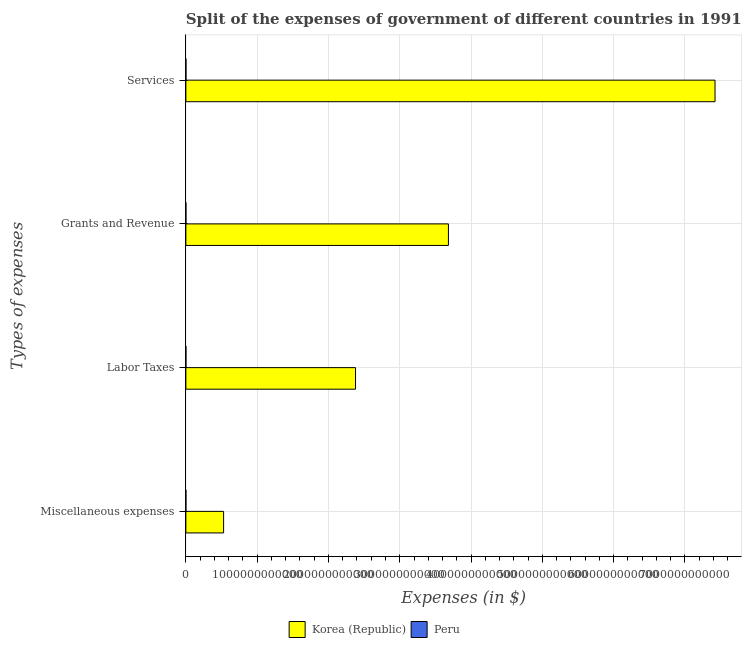How many different coloured bars are there?
Your answer should be compact. 2. How many groups of bars are there?
Your response must be concise. 4. How many bars are there on the 4th tick from the bottom?
Keep it short and to the point. 2. What is the label of the 4th group of bars from the top?
Your answer should be very brief. Miscellaneous expenses. What is the amount spent on grants and revenue in Peru?
Your answer should be compact. 2.74e+08. Across all countries, what is the maximum amount spent on grants and revenue?
Provide a succinct answer. 3.68e+12. Across all countries, what is the minimum amount spent on miscellaneous expenses?
Make the answer very short. 5.00e+06. In which country was the amount spent on grants and revenue maximum?
Offer a very short reply. Korea (Republic). In which country was the amount spent on grants and revenue minimum?
Keep it short and to the point. Peru. What is the total amount spent on labor taxes in the graph?
Your response must be concise. 2.38e+12. What is the difference between the amount spent on miscellaneous expenses in Peru and that in Korea (Republic)?
Provide a short and direct response. -5.29e+11. What is the difference between the amount spent on labor taxes in Peru and the amount spent on grants and revenue in Korea (Republic)?
Ensure brevity in your answer.  -3.68e+12. What is the average amount spent on miscellaneous expenses per country?
Offer a terse response. 2.65e+11. What is the difference between the amount spent on miscellaneous expenses and amount spent on grants and revenue in Korea (Republic)?
Provide a succinct answer. -3.15e+12. In how many countries, is the amount spent on services greater than 3400000000000 $?
Offer a very short reply. 1. What is the ratio of the amount spent on services in Peru to that in Korea (Republic)?
Your answer should be compact. 8.04257038933046e-5. Is the amount spent on miscellaneous expenses in Korea (Republic) less than that in Peru?
Your answer should be very brief. No. What is the difference between the highest and the second highest amount spent on miscellaneous expenses?
Your answer should be compact. 5.29e+11. What is the difference between the highest and the lowest amount spent on miscellaneous expenses?
Offer a terse response. 5.29e+11. In how many countries, is the amount spent on labor taxes greater than the average amount spent on labor taxes taken over all countries?
Your answer should be compact. 1. Is it the case that in every country, the sum of the amount spent on services and amount spent on miscellaneous expenses is greater than the sum of amount spent on labor taxes and amount spent on grants and revenue?
Ensure brevity in your answer.  No. Is it the case that in every country, the sum of the amount spent on miscellaneous expenses and amount spent on labor taxes is greater than the amount spent on grants and revenue?
Your answer should be very brief. No. Are all the bars in the graph horizontal?
Make the answer very short. Yes. How many countries are there in the graph?
Your response must be concise. 2. What is the difference between two consecutive major ticks on the X-axis?
Your answer should be very brief. 1.00e+12. Does the graph contain any zero values?
Provide a succinct answer. No. Does the graph contain grids?
Your response must be concise. Yes. What is the title of the graph?
Make the answer very short. Split of the expenses of government of different countries in 1991. What is the label or title of the X-axis?
Your response must be concise. Expenses (in $). What is the label or title of the Y-axis?
Your answer should be very brief. Types of expenses. What is the Expenses (in $) in Korea (Republic) in Miscellaneous expenses?
Provide a succinct answer. 5.29e+11. What is the Expenses (in $) in Peru in Miscellaneous expenses?
Provide a short and direct response. 5.00e+06. What is the Expenses (in $) in Korea (Republic) in Labor Taxes?
Your answer should be very brief. 2.38e+12. What is the Expenses (in $) of Peru in Labor Taxes?
Provide a short and direct response. 4.48e+08. What is the Expenses (in $) in Korea (Republic) in Grants and Revenue?
Ensure brevity in your answer.  3.68e+12. What is the Expenses (in $) of Peru in Grants and Revenue?
Your response must be concise. 2.74e+08. What is the Expenses (in $) in Korea (Republic) in Services?
Give a very brief answer. 7.42e+12. What is the Expenses (in $) in Peru in Services?
Provide a succinct answer. 5.97e+08. Across all Types of expenses, what is the maximum Expenses (in $) in Korea (Republic)?
Provide a succinct answer. 7.42e+12. Across all Types of expenses, what is the maximum Expenses (in $) of Peru?
Give a very brief answer. 5.97e+08. Across all Types of expenses, what is the minimum Expenses (in $) in Korea (Republic)?
Offer a very short reply. 5.29e+11. What is the total Expenses (in $) of Korea (Republic) in the graph?
Your answer should be compact. 1.40e+13. What is the total Expenses (in $) of Peru in the graph?
Ensure brevity in your answer.  1.32e+09. What is the difference between the Expenses (in $) of Korea (Republic) in Miscellaneous expenses and that in Labor Taxes?
Make the answer very short. -1.85e+12. What is the difference between the Expenses (in $) of Peru in Miscellaneous expenses and that in Labor Taxes?
Provide a succinct answer. -4.43e+08. What is the difference between the Expenses (in $) of Korea (Republic) in Miscellaneous expenses and that in Grants and Revenue?
Offer a terse response. -3.15e+12. What is the difference between the Expenses (in $) in Peru in Miscellaneous expenses and that in Grants and Revenue?
Provide a succinct answer. -2.69e+08. What is the difference between the Expenses (in $) of Korea (Republic) in Miscellaneous expenses and that in Services?
Provide a short and direct response. -6.89e+12. What is the difference between the Expenses (in $) of Peru in Miscellaneous expenses and that in Services?
Your answer should be very brief. -5.92e+08. What is the difference between the Expenses (in $) of Korea (Republic) in Labor Taxes and that in Grants and Revenue?
Your answer should be compact. -1.30e+12. What is the difference between the Expenses (in $) in Peru in Labor Taxes and that in Grants and Revenue?
Ensure brevity in your answer.  1.74e+08. What is the difference between the Expenses (in $) in Korea (Republic) in Labor Taxes and that in Services?
Give a very brief answer. -5.04e+12. What is the difference between the Expenses (in $) of Peru in Labor Taxes and that in Services?
Ensure brevity in your answer.  -1.49e+08. What is the difference between the Expenses (in $) of Korea (Republic) in Grants and Revenue and that in Services?
Offer a very short reply. -3.74e+12. What is the difference between the Expenses (in $) in Peru in Grants and Revenue and that in Services?
Give a very brief answer. -3.23e+08. What is the difference between the Expenses (in $) in Korea (Republic) in Miscellaneous expenses and the Expenses (in $) in Peru in Labor Taxes?
Keep it short and to the point. 5.29e+11. What is the difference between the Expenses (in $) in Korea (Republic) in Miscellaneous expenses and the Expenses (in $) in Peru in Grants and Revenue?
Provide a short and direct response. 5.29e+11. What is the difference between the Expenses (in $) in Korea (Republic) in Miscellaneous expenses and the Expenses (in $) in Peru in Services?
Ensure brevity in your answer.  5.28e+11. What is the difference between the Expenses (in $) of Korea (Republic) in Labor Taxes and the Expenses (in $) of Peru in Grants and Revenue?
Your answer should be very brief. 2.38e+12. What is the difference between the Expenses (in $) in Korea (Republic) in Labor Taxes and the Expenses (in $) in Peru in Services?
Ensure brevity in your answer.  2.38e+12. What is the difference between the Expenses (in $) in Korea (Republic) in Grants and Revenue and the Expenses (in $) in Peru in Services?
Provide a succinct answer. 3.68e+12. What is the average Expenses (in $) in Korea (Republic) per Types of expenses?
Keep it short and to the point. 3.50e+12. What is the average Expenses (in $) in Peru per Types of expenses?
Your answer should be compact. 3.31e+08. What is the difference between the Expenses (in $) in Korea (Republic) and Expenses (in $) in Peru in Miscellaneous expenses?
Your answer should be very brief. 5.29e+11. What is the difference between the Expenses (in $) in Korea (Republic) and Expenses (in $) in Peru in Labor Taxes?
Your answer should be compact. 2.38e+12. What is the difference between the Expenses (in $) of Korea (Republic) and Expenses (in $) of Peru in Grants and Revenue?
Keep it short and to the point. 3.68e+12. What is the difference between the Expenses (in $) of Korea (Republic) and Expenses (in $) of Peru in Services?
Your answer should be very brief. 7.42e+12. What is the ratio of the Expenses (in $) of Korea (Republic) in Miscellaneous expenses to that in Labor Taxes?
Provide a succinct answer. 0.22. What is the ratio of the Expenses (in $) of Peru in Miscellaneous expenses to that in Labor Taxes?
Give a very brief answer. 0.01. What is the ratio of the Expenses (in $) of Korea (Republic) in Miscellaneous expenses to that in Grants and Revenue?
Keep it short and to the point. 0.14. What is the ratio of the Expenses (in $) in Peru in Miscellaneous expenses to that in Grants and Revenue?
Keep it short and to the point. 0.02. What is the ratio of the Expenses (in $) of Korea (Republic) in Miscellaneous expenses to that in Services?
Make the answer very short. 0.07. What is the ratio of the Expenses (in $) in Peru in Miscellaneous expenses to that in Services?
Provide a short and direct response. 0.01. What is the ratio of the Expenses (in $) in Korea (Republic) in Labor Taxes to that in Grants and Revenue?
Offer a terse response. 0.65. What is the ratio of the Expenses (in $) of Peru in Labor Taxes to that in Grants and Revenue?
Your answer should be compact. 1.63. What is the ratio of the Expenses (in $) in Korea (Republic) in Labor Taxes to that in Services?
Your answer should be compact. 0.32. What is the ratio of the Expenses (in $) of Korea (Republic) in Grants and Revenue to that in Services?
Your response must be concise. 0.5. What is the ratio of the Expenses (in $) of Peru in Grants and Revenue to that in Services?
Make the answer very short. 0.46. What is the difference between the highest and the second highest Expenses (in $) in Korea (Republic)?
Offer a very short reply. 3.74e+12. What is the difference between the highest and the second highest Expenses (in $) in Peru?
Provide a short and direct response. 1.49e+08. What is the difference between the highest and the lowest Expenses (in $) in Korea (Republic)?
Offer a very short reply. 6.89e+12. What is the difference between the highest and the lowest Expenses (in $) of Peru?
Ensure brevity in your answer.  5.92e+08. 